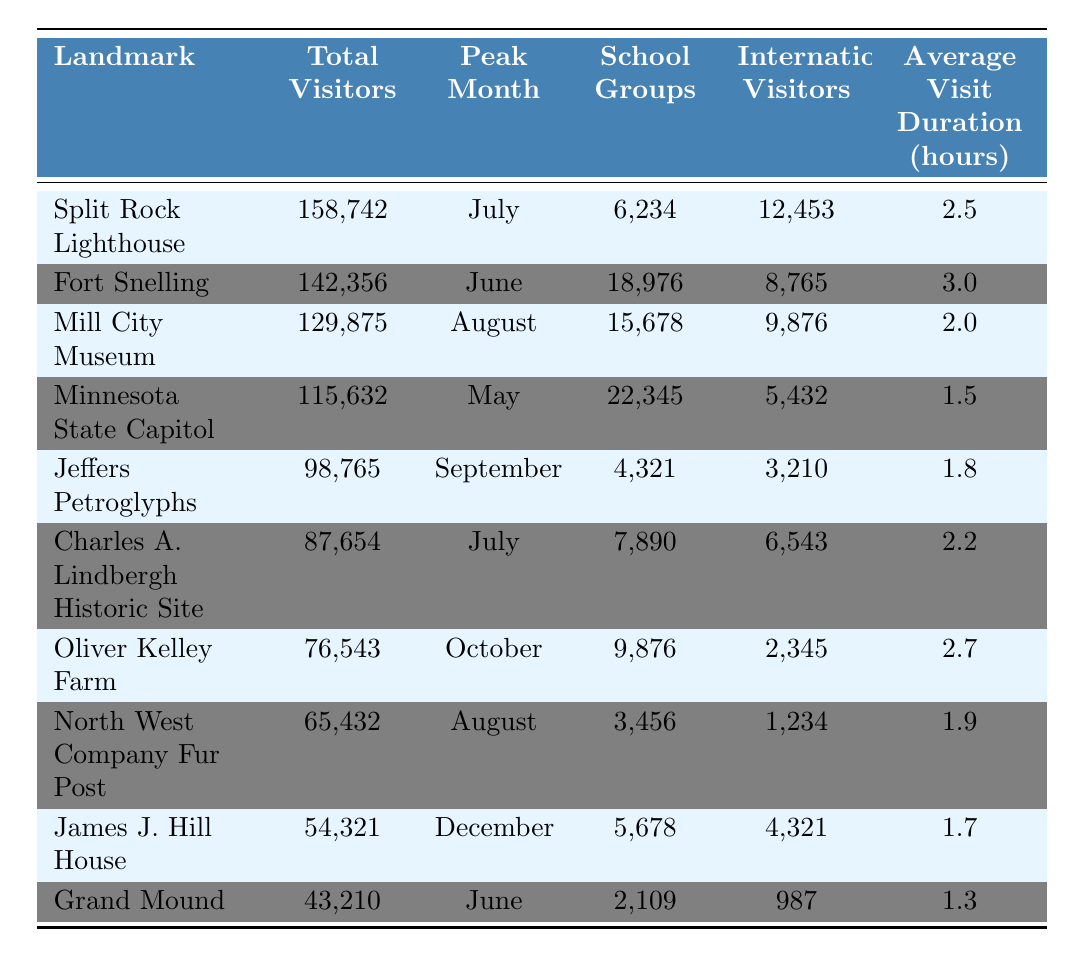What is the total number of visitors to Split Rock Lighthouse? The table shows that Split Rock Lighthouse had a total of 158,742 visitors in 2022.
Answer: 158742 Which landmark had the highest number of international visitors? By comparing the 'International Visitors' column, Split Rock Lighthouse has 12,453 international visitors, which is higher than any other landmark.
Answer: Split Rock Lighthouse What is the peak month for Fort Snelling? The table indicates that the peak month for Fort Snelling is June.
Answer: June How many school groups visited the Minnesota State Capitol? The 'School Groups' column for the Minnesota State Capitol shows a total of 22,345 visitors from school groups.
Answer: 22345 What are the average visit durations for the top three landmarks? The average visit durations for the top three landmarks are: Split Rock Lighthouse (2.5 hours), Fort Snelling (3.0 hours), and Mill City Museum (2.0 hours). The sum is 2.5 + 3.0 + 2.0 = 7.5 hours, and the average is 7.5/3 = 2.5 hours.
Answer: 2.5 hours How many total visitors did all landmarks combined attract in 2022? Adding all the 'Total Visitors' values gives us 158,742 + 142,356 + 129,875 + 115,632 + 98,765 + 87,654 + 76,543 + 65,432 + 54,321 + 43,210 = 1,032,524.
Answer: 1032524 Which landmark had the lowest number of visitors and how many were there? The lowest number of visitors is seen for Grand Mound, which had a total of 43,210 visitors.
Answer: Grand Mound, 43210 Did Oliver Kelley Farm attract more visitors than James J. Hill House? Comparing the totals, Oliver Kelley Farm had 76,543 visitors, while James J. Hill House had 54,321 visitors, so yes, Oliver Kelley Farm attracted more visitors.
Answer: Yes What was the average duration of visits for landmarks with peak months in the summer (June, July, August)? The landmarks with peak months in the summer are Fort Snelling (3.0 hours), Split Rock Lighthouse (2.5 hours), Mill City Museum (2.0 hours), and Oliver Kelley Farm (2.7 hours). The average duration is (3.0 + 2.5 + 2.0 + 2.7) / 4 = 2.575 hours.
Answer: 2.575 hours How many more international visitors did the Split Rock Lighthouse have compared to the Grand Mound? The Split Rock Lighthouse had 12,453 international visitors, while Grand Mound had 987. The difference is 12,453 - 987 = 11,466 visitors.
Answer: 11466 